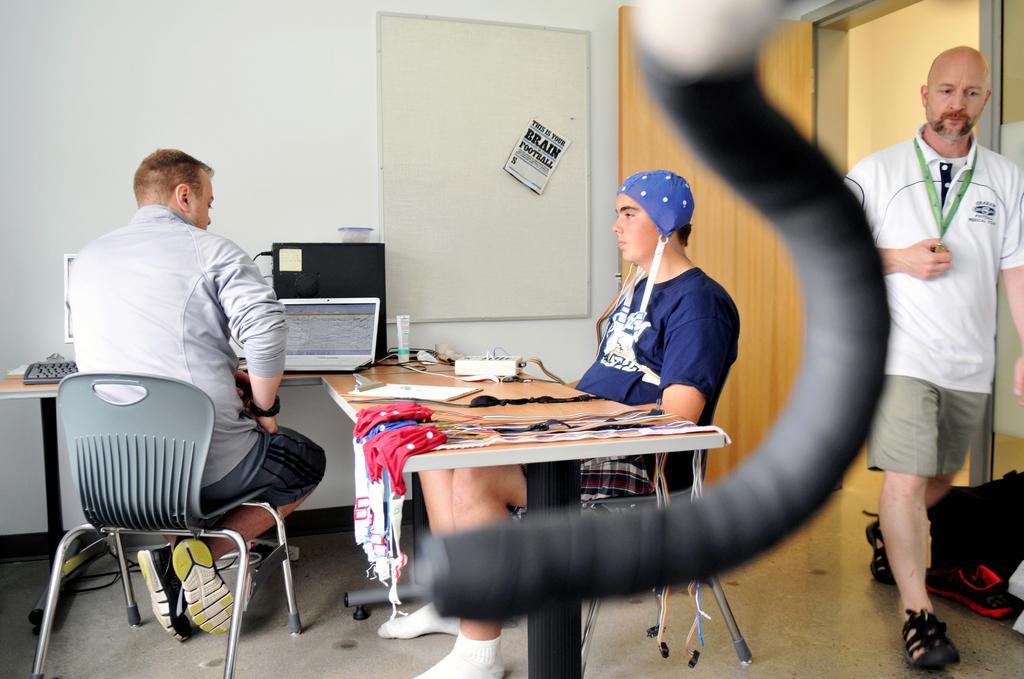Could you give a brief overview of what you see in this image? In this image I see 3 men in which one of them is standing and 2 of them are on the chairs. In the background I see the wall, door, laptop and a few things on the table. 